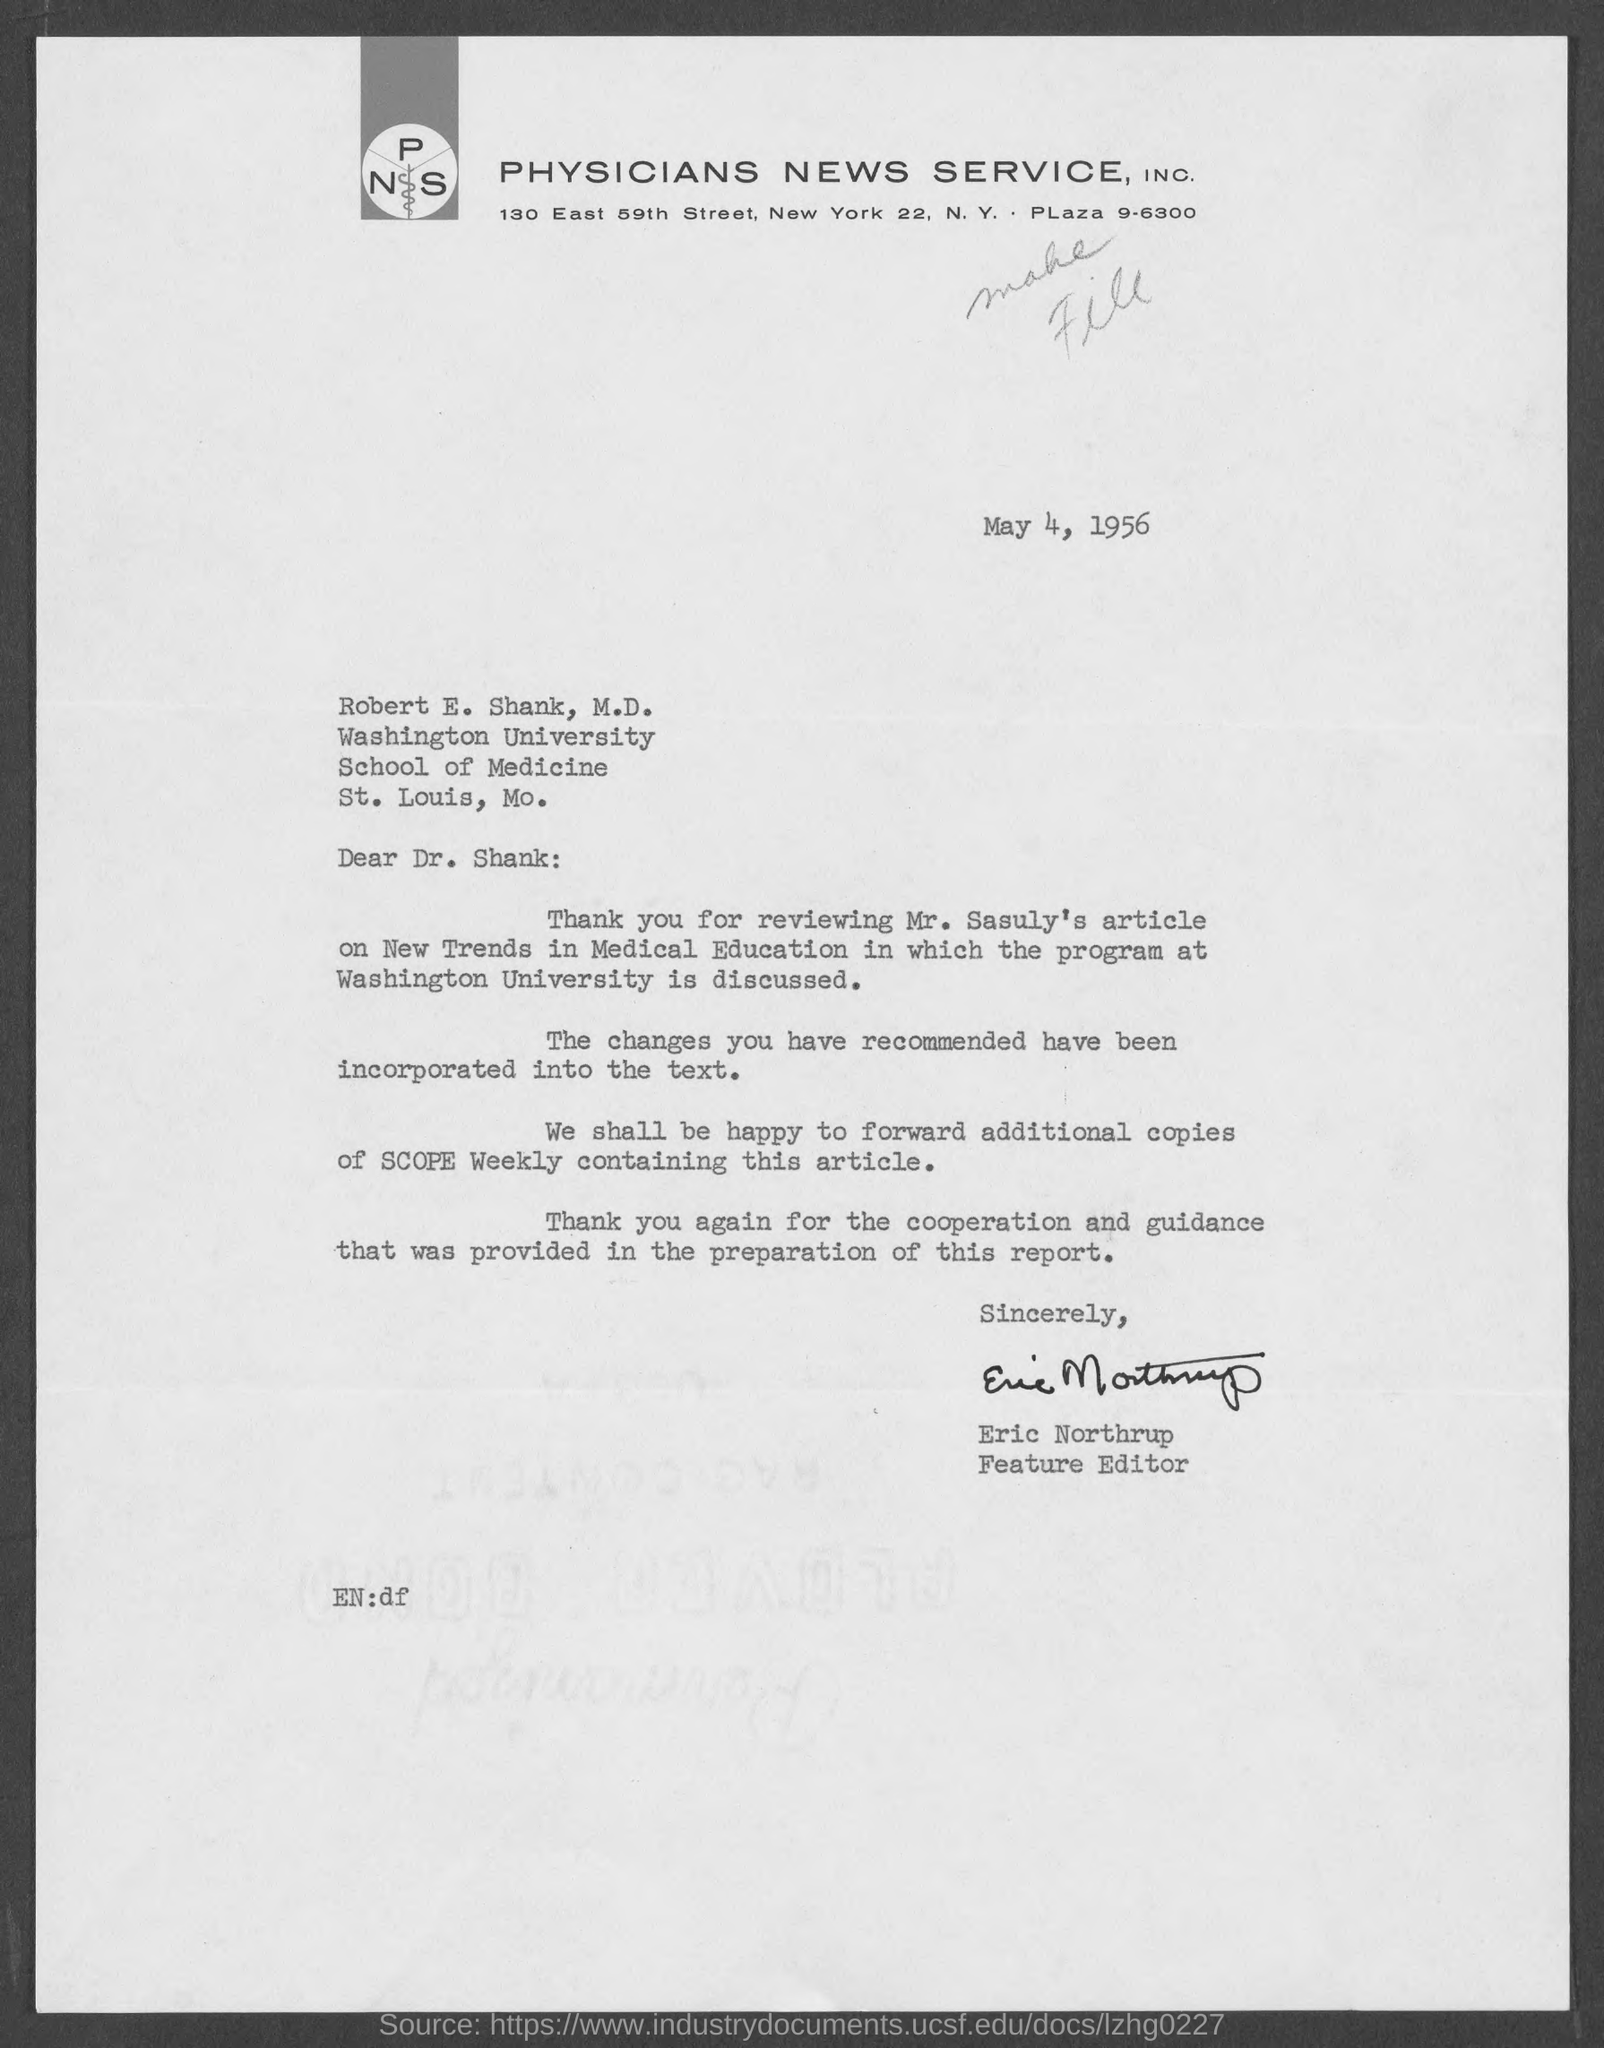Point out several critical features in this image. The feature editor is Eric Northrup. The date mentioned is May 4, 1956. This letter is written to Robert E. Shank, M.D. Physicians News Service, Inc. is located in New York City. Robert E. Shank is a member of Washington University. 